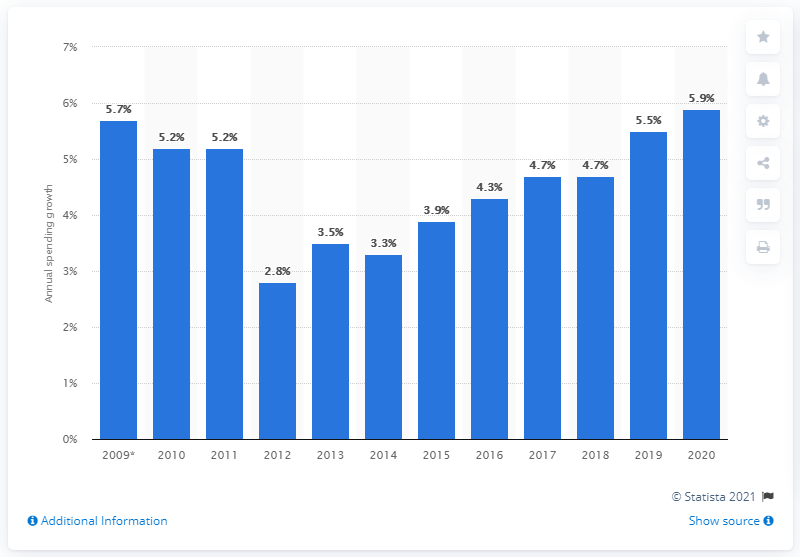Give some essential details in this illustration. The expenditures on the treatment of mental health increased by 5.7% from 2008 to 2009. 